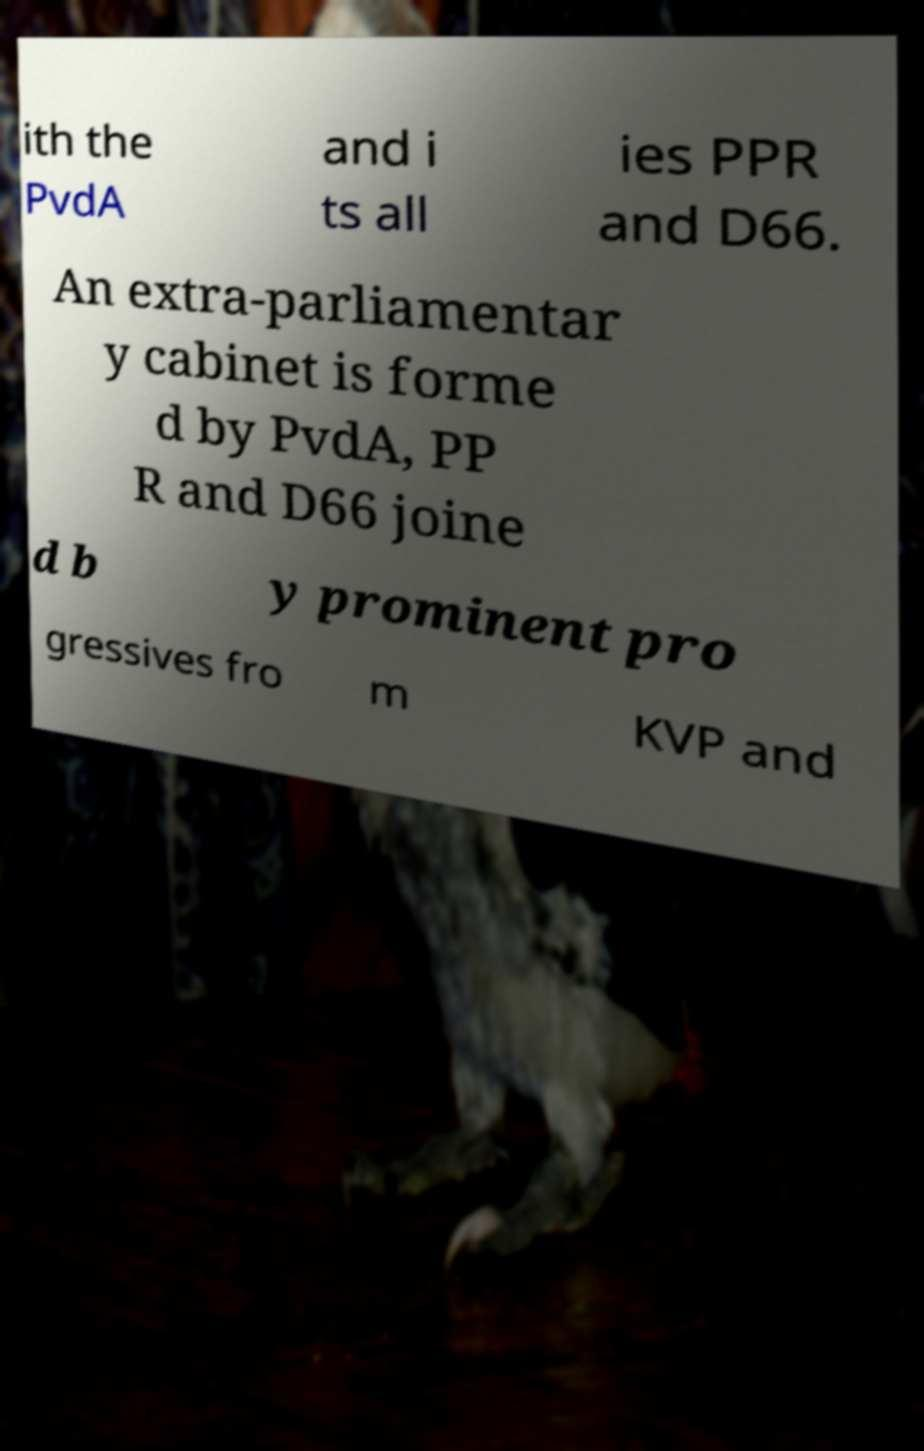Please identify and transcribe the text found in this image. ith the PvdA and i ts all ies PPR and D66. An extra-parliamentar y cabinet is forme d by PvdA, PP R and D66 joine d b y prominent pro gressives fro m KVP and 